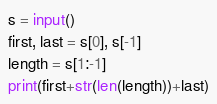Convert code to text. <code><loc_0><loc_0><loc_500><loc_500><_Python_>s = input()
first, last = s[0], s[-1]
length = s[1:-1]
print(first+str(len(length))+last)
</code> 